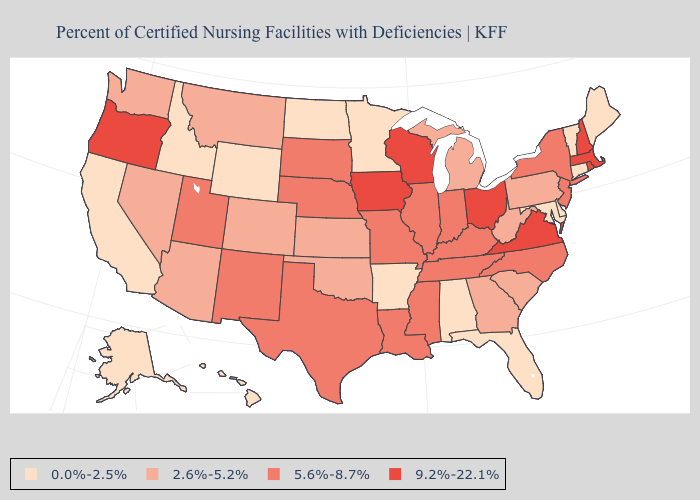Among the states that border South Carolina , which have the lowest value?
Short answer required. Georgia. What is the value of New Mexico?
Give a very brief answer. 5.6%-8.7%. Name the states that have a value in the range 2.6%-5.2%?
Keep it brief. Arizona, Colorado, Georgia, Kansas, Michigan, Montana, Nevada, Oklahoma, Pennsylvania, South Carolina, Washington, West Virginia. Name the states that have a value in the range 5.6%-8.7%?
Quick response, please. Illinois, Indiana, Kentucky, Louisiana, Mississippi, Missouri, Nebraska, New Jersey, New Mexico, New York, North Carolina, South Dakota, Tennessee, Texas, Utah. What is the highest value in the South ?
Keep it brief. 9.2%-22.1%. Which states have the lowest value in the MidWest?
Short answer required. Minnesota, North Dakota. Does Delaware have a higher value than West Virginia?
Concise answer only. No. Which states hav the highest value in the West?
Quick response, please. Oregon. What is the value of New Mexico?
Short answer required. 5.6%-8.7%. What is the value of Rhode Island?
Quick response, please. 9.2%-22.1%. Which states have the highest value in the USA?
Keep it brief. Iowa, Massachusetts, New Hampshire, Ohio, Oregon, Rhode Island, Virginia, Wisconsin. Name the states that have a value in the range 5.6%-8.7%?
Write a very short answer. Illinois, Indiana, Kentucky, Louisiana, Mississippi, Missouri, Nebraska, New Jersey, New Mexico, New York, North Carolina, South Dakota, Tennessee, Texas, Utah. Among the states that border South Carolina , which have the lowest value?
Write a very short answer. Georgia. Name the states that have a value in the range 2.6%-5.2%?
Quick response, please. Arizona, Colorado, Georgia, Kansas, Michigan, Montana, Nevada, Oklahoma, Pennsylvania, South Carolina, Washington, West Virginia. Name the states that have a value in the range 2.6%-5.2%?
Short answer required. Arizona, Colorado, Georgia, Kansas, Michigan, Montana, Nevada, Oklahoma, Pennsylvania, South Carolina, Washington, West Virginia. 